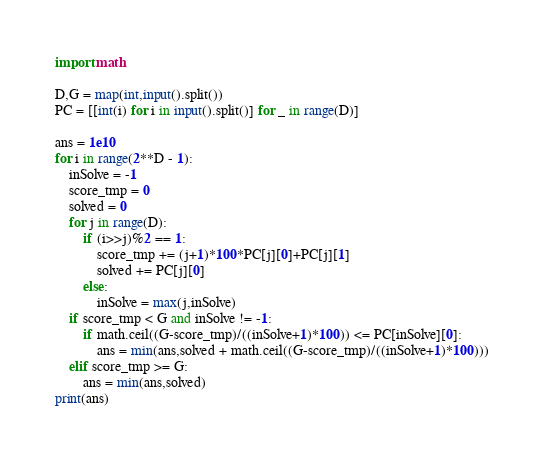Convert code to text. <code><loc_0><loc_0><loc_500><loc_500><_Python_>import math

D,G = map(int,input().split())
PC = [[int(i) for i in input().split()] for _ in range(D)]

ans = 1e10
for i in range(2**D - 1):
    inSolve = -1
    score_tmp = 0
    solved = 0
    for j in range(D):
        if (i>>j)%2 == 1:
            score_tmp += (j+1)*100*PC[j][0]+PC[j][1]
            solved += PC[j][0]
        else:
            inSolve = max(j,inSolve)
    if score_tmp < G and inSolve != -1:
        if math.ceil((G-score_tmp)/((inSolve+1)*100)) <= PC[inSolve][0]:
            ans = min(ans,solved + math.ceil((G-score_tmp)/((inSolve+1)*100)))
    elif score_tmp >= G:
        ans = min(ans,solved)
print(ans)
</code> 